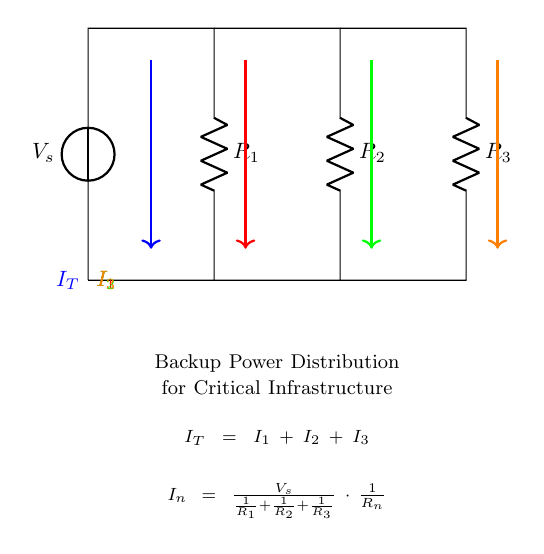What is the source voltage in this backup power distribution circuit? The source voltage is labeled as V_s at the top of the circuit diagram, indicating the voltage supply for the circuit.
Answer: V_s What are the resistance values in this circuit? The resistances are labeled as R_1, R_2, and R_3, representing individual resistors in the current divider. The specific numerical values are not given, but they are clearly denoted.
Answer: R_1, R_2, R_3 What is the total current entering the backup power distribution system? The total current is labeled as I_T, which represents the sum of the branch currents I_1, I_2, and I_3 flowing from the voltage source into the resistors.
Answer: I_T How is the current divided among the resistors? The current division principle states that the current flowing through each resistor in parallel is inversely proportional to its resistance; thus, total current I_T splits into I_1, I_2, and I_3 based on the respective values of R_1, R_2, and R_3.
Answer: Current division principle How do you calculate the current through a specific resistor? The current through a resistor can be calculated using the formula I_n = V_s / (1/R_1 + 1/R_2 + 1/R_3) * (1/R_n), where R_n is the resistance of the resistor of interest, showing that it depends on both the source voltage and the total resistance of the circuit.
Answer: I_n formula What relationship do the currents I_1, I_2, and I_3 have with I_T? The relationship is expressed in the equation I_T = I_1 + I_2 + I_3, meaning that the sum of currents in all branches equals the total current entering the circuit.
Answer: I_T = I_1 + I_2 + I_3 